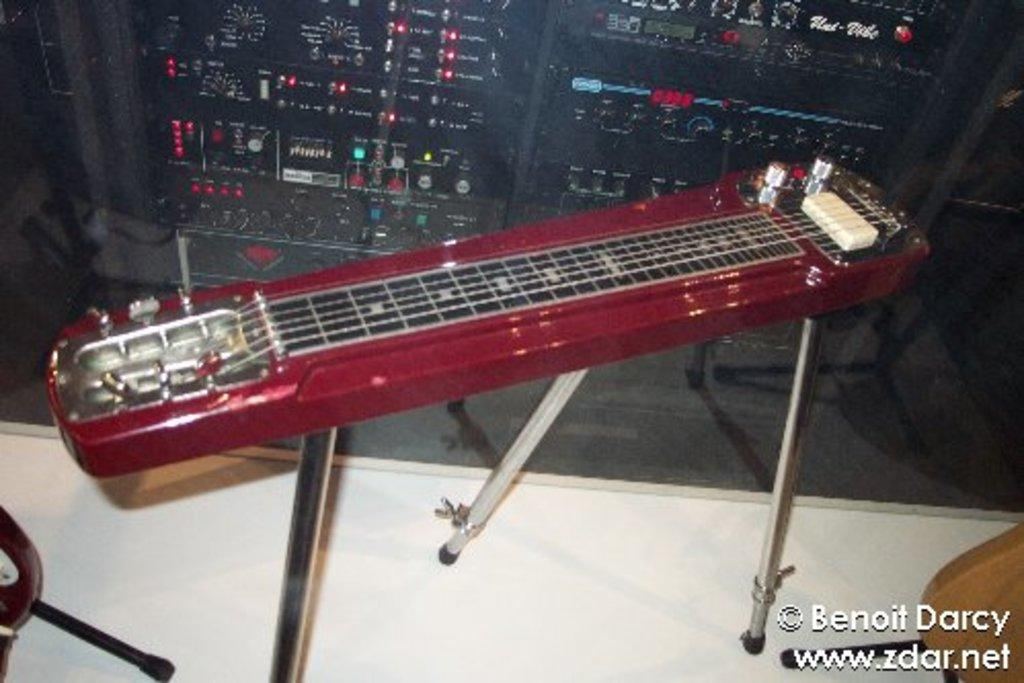What objects are on the table in the image? There are musical instruments on a table in the image. What can be seen in the background of the image? There is a music rack system and a stand in the background. What type of calculator is on the stand in the image? There is no calculator present in the image; the stand is associated with the music rack system. 